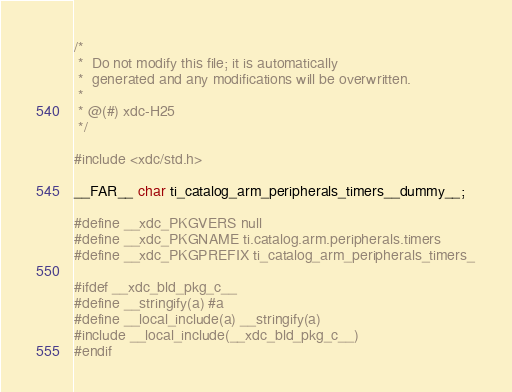Convert code to text. <code><loc_0><loc_0><loc_500><loc_500><_C_>/*
 *  Do not modify this file; it is automatically 
 *  generated and any modifications will be overwritten.
 *
 * @(#) xdc-H25
 */

#include <xdc/std.h>

__FAR__ char ti_catalog_arm_peripherals_timers__dummy__;

#define __xdc_PKGVERS null
#define __xdc_PKGNAME ti.catalog.arm.peripherals.timers
#define __xdc_PKGPREFIX ti_catalog_arm_peripherals_timers_

#ifdef __xdc_bld_pkg_c__
#define __stringify(a) #a
#define __local_include(a) __stringify(a)
#include __local_include(__xdc_bld_pkg_c__)
#endif

</code> 